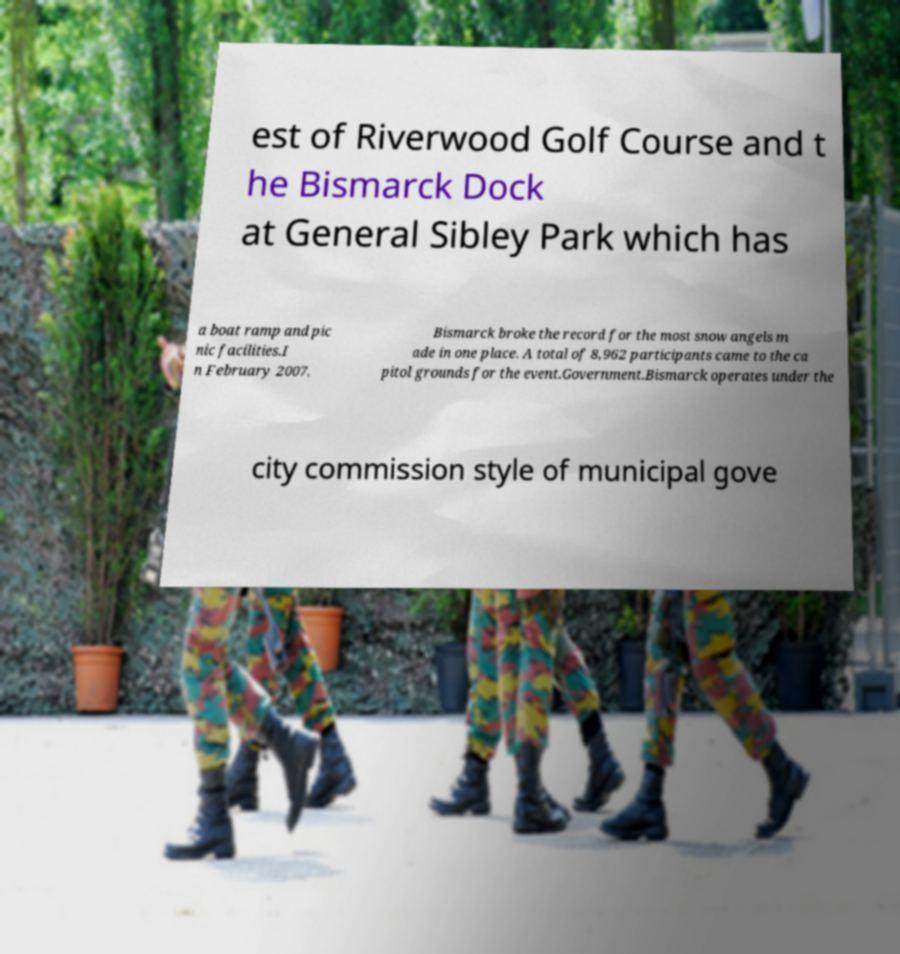For documentation purposes, I need the text within this image transcribed. Could you provide that? est of Riverwood Golf Course and t he Bismarck Dock at General Sibley Park which has a boat ramp and pic nic facilities.I n February 2007, Bismarck broke the record for the most snow angels m ade in one place. A total of 8,962 participants came to the ca pitol grounds for the event.Government.Bismarck operates under the city commission style of municipal gove 